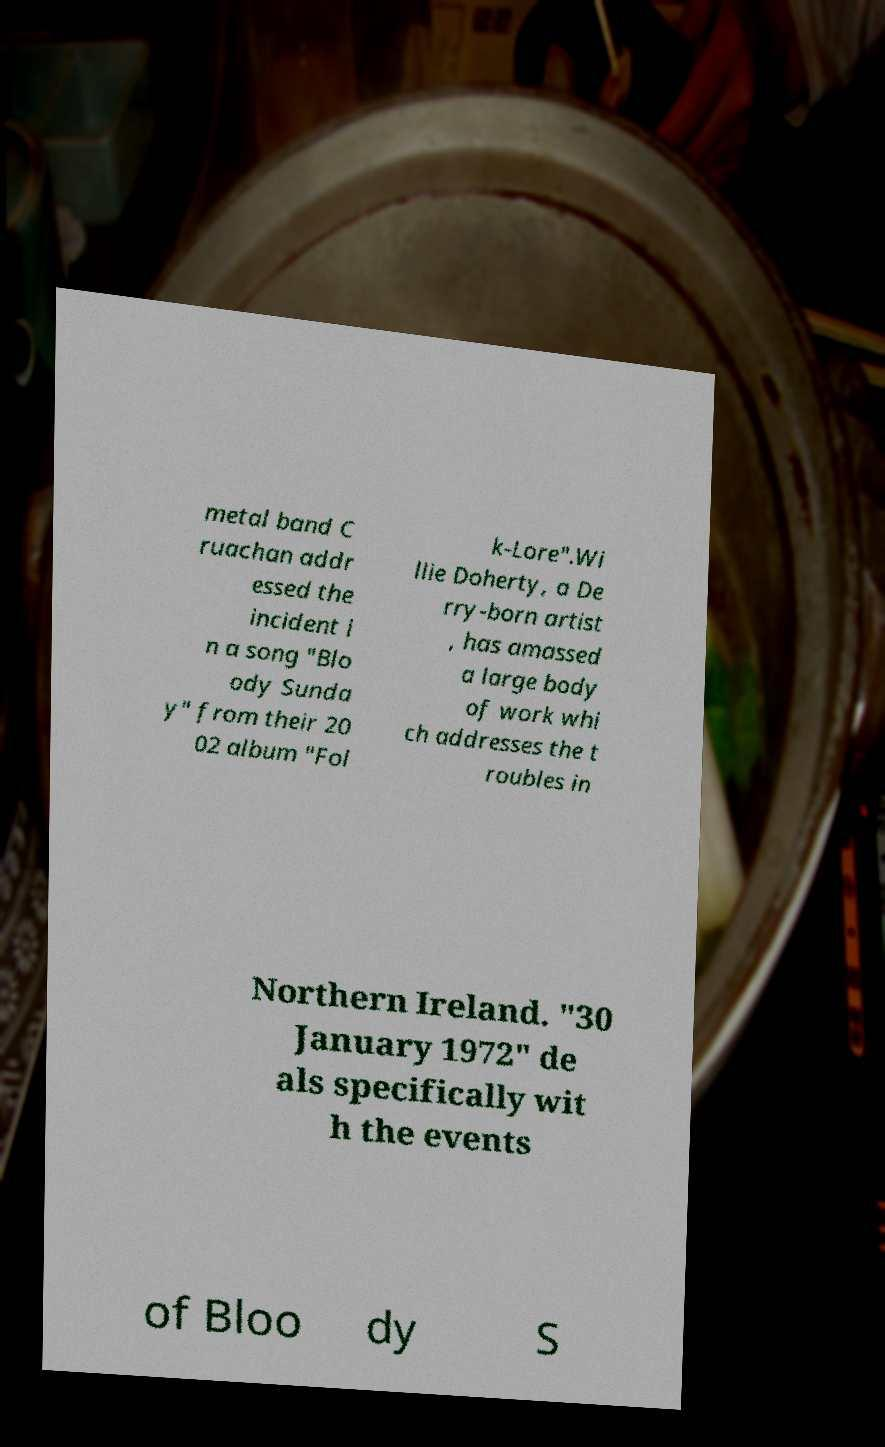Could you assist in decoding the text presented in this image and type it out clearly? metal band C ruachan addr essed the incident i n a song "Blo ody Sunda y" from their 20 02 album "Fol k-Lore".Wi llie Doherty, a De rry-born artist , has amassed a large body of work whi ch addresses the t roubles in Northern Ireland. "30 January 1972" de als specifically wit h the events of Bloo dy S 